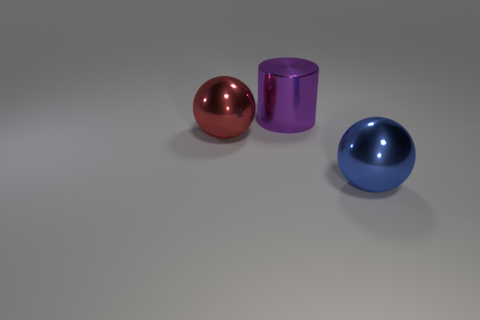Do the red shiny thing and the thing in front of the large red ball have the same size?
Offer a terse response. Yes. Are there fewer purple shiny cylinders left of the big red object than big green metal cubes?
Your answer should be compact. No. There is another thing that is the same shape as the red metal thing; what is it made of?
Provide a short and direct response. Metal. What is the shape of the big thing that is right of the red object and in front of the purple thing?
Your response must be concise. Sphere. The red thing that is the same material as the blue object is what shape?
Your response must be concise. Sphere. There is a sphere on the left side of the large blue object; what material is it?
Make the answer very short. Metal. There is a shiny sphere to the left of the blue metallic thing; is its size the same as the metallic ball in front of the red object?
Ensure brevity in your answer.  Yes. What color is the shiny cylinder?
Provide a succinct answer. Purple. There is a large thing that is behind the red thing; is its shape the same as the blue shiny object?
Your answer should be very brief. No. What material is the big blue sphere?
Give a very brief answer. Metal. 